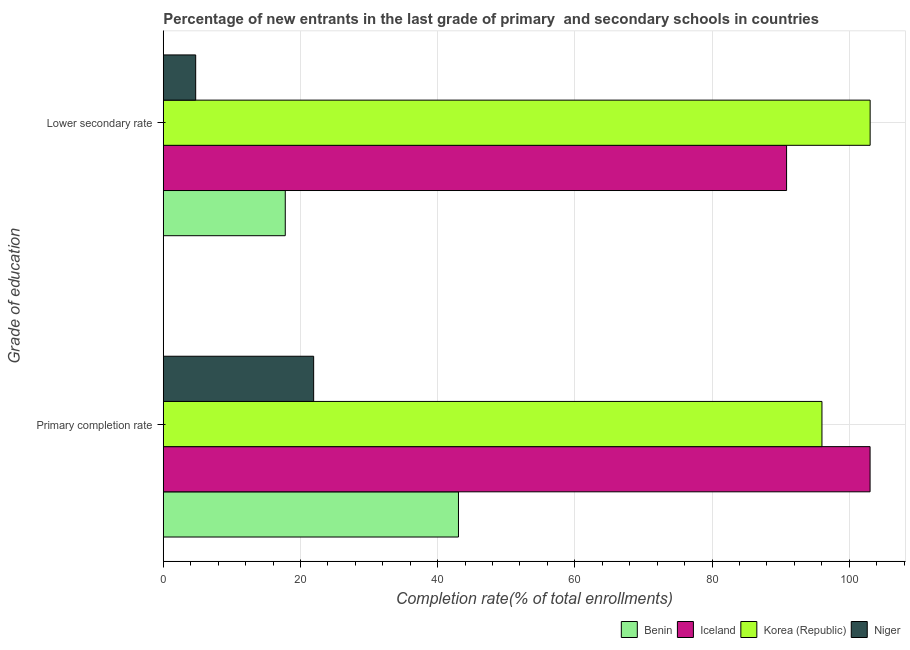How many different coloured bars are there?
Your answer should be compact. 4. Are the number of bars on each tick of the Y-axis equal?
Provide a short and direct response. Yes. How many bars are there on the 1st tick from the top?
Your response must be concise. 4. How many bars are there on the 2nd tick from the bottom?
Keep it short and to the point. 4. What is the label of the 2nd group of bars from the top?
Keep it short and to the point. Primary completion rate. What is the completion rate in secondary schools in Benin?
Offer a very short reply. 17.78. Across all countries, what is the maximum completion rate in secondary schools?
Offer a very short reply. 103.05. Across all countries, what is the minimum completion rate in primary schools?
Offer a terse response. 21.92. In which country was the completion rate in primary schools minimum?
Offer a very short reply. Niger. What is the total completion rate in secondary schools in the graph?
Provide a succinct answer. 216.42. What is the difference between the completion rate in secondary schools in Niger and that in Iceland?
Provide a succinct answer. -86.14. What is the difference between the completion rate in secondary schools in Korea (Republic) and the completion rate in primary schools in Benin?
Provide a short and direct response. 60.01. What is the average completion rate in primary schools per country?
Your answer should be compact. 66. What is the difference between the completion rate in secondary schools and completion rate in primary schools in Niger?
Provide a short and direct response. -17.2. What is the ratio of the completion rate in secondary schools in Niger to that in Benin?
Offer a terse response. 0.27. In how many countries, is the completion rate in secondary schools greater than the average completion rate in secondary schools taken over all countries?
Ensure brevity in your answer.  2. What does the 3rd bar from the top in Lower secondary rate represents?
Your answer should be compact. Iceland. What does the 3rd bar from the bottom in Lower secondary rate represents?
Ensure brevity in your answer.  Korea (Republic). Are all the bars in the graph horizontal?
Your answer should be compact. Yes. What is the difference between two consecutive major ticks on the X-axis?
Make the answer very short. 20. Are the values on the major ticks of X-axis written in scientific E-notation?
Offer a terse response. No. Does the graph contain grids?
Offer a terse response. Yes. How many legend labels are there?
Your answer should be compact. 4. How are the legend labels stacked?
Keep it short and to the point. Horizontal. What is the title of the graph?
Make the answer very short. Percentage of new entrants in the last grade of primary  and secondary schools in countries. Does "Aruba" appear as one of the legend labels in the graph?
Provide a short and direct response. No. What is the label or title of the X-axis?
Provide a succinct answer. Completion rate(% of total enrollments). What is the label or title of the Y-axis?
Give a very brief answer. Grade of education. What is the Completion rate(% of total enrollments) in Benin in Primary completion rate?
Ensure brevity in your answer.  43.03. What is the Completion rate(% of total enrollments) of Iceland in Primary completion rate?
Provide a short and direct response. 103.04. What is the Completion rate(% of total enrollments) in Korea (Republic) in Primary completion rate?
Your response must be concise. 96.02. What is the Completion rate(% of total enrollments) of Niger in Primary completion rate?
Keep it short and to the point. 21.92. What is the Completion rate(% of total enrollments) in Benin in Lower secondary rate?
Your answer should be compact. 17.78. What is the Completion rate(% of total enrollments) in Iceland in Lower secondary rate?
Your response must be concise. 90.86. What is the Completion rate(% of total enrollments) in Korea (Republic) in Lower secondary rate?
Make the answer very short. 103.05. What is the Completion rate(% of total enrollments) in Niger in Lower secondary rate?
Your answer should be compact. 4.73. Across all Grade of education, what is the maximum Completion rate(% of total enrollments) in Benin?
Keep it short and to the point. 43.03. Across all Grade of education, what is the maximum Completion rate(% of total enrollments) of Iceland?
Give a very brief answer. 103.04. Across all Grade of education, what is the maximum Completion rate(% of total enrollments) in Korea (Republic)?
Your answer should be compact. 103.05. Across all Grade of education, what is the maximum Completion rate(% of total enrollments) of Niger?
Your answer should be very brief. 21.92. Across all Grade of education, what is the minimum Completion rate(% of total enrollments) in Benin?
Your answer should be very brief. 17.78. Across all Grade of education, what is the minimum Completion rate(% of total enrollments) of Iceland?
Your answer should be compact. 90.86. Across all Grade of education, what is the minimum Completion rate(% of total enrollments) of Korea (Republic)?
Your answer should be compact. 96.02. Across all Grade of education, what is the minimum Completion rate(% of total enrollments) in Niger?
Make the answer very short. 4.73. What is the total Completion rate(% of total enrollments) in Benin in the graph?
Your response must be concise. 60.82. What is the total Completion rate(% of total enrollments) of Iceland in the graph?
Offer a terse response. 193.9. What is the total Completion rate(% of total enrollments) of Korea (Republic) in the graph?
Your answer should be compact. 199.07. What is the total Completion rate(% of total enrollments) of Niger in the graph?
Offer a terse response. 26.65. What is the difference between the Completion rate(% of total enrollments) of Benin in Primary completion rate and that in Lower secondary rate?
Keep it short and to the point. 25.25. What is the difference between the Completion rate(% of total enrollments) in Iceland in Primary completion rate and that in Lower secondary rate?
Provide a succinct answer. 12.17. What is the difference between the Completion rate(% of total enrollments) of Korea (Republic) in Primary completion rate and that in Lower secondary rate?
Your response must be concise. -7.02. What is the difference between the Completion rate(% of total enrollments) in Niger in Primary completion rate and that in Lower secondary rate?
Your answer should be very brief. 17.2. What is the difference between the Completion rate(% of total enrollments) of Benin in Primary completion rate and the Completion rate(% of total enrollments) of Iceland in Lower secondary rate?
Provide a short and direct response. -47.83. What is the difference between the Completion rate(% of total enrollments) in Benin in Primary completion rate and the Completion rate(% of total enrollments) in Korea (Republic) in Lower secondary rate?
Ensure brevity in your answer.  -60.01. What is the difference between the Completion rate(% of total enrollments) of Benin in Primary completion rate and the Completion rate(% of total enrollments) of Niger in Lower secondary rate?
Offer a very short reply. 38.31. What is the difference between the Completion rate(% of total enrollments) in Iceland in Primary completion rate and the Completion rate(% of total enrollments) in Korea (Republic) in Lower secondary rate?
Provide a short and direct response. -0.01. What is the difference between the Completion rate(% of total enrollments) of Iceland in Primary completion rate and the Completion rate(% of total enrollments) of Niger in Lower secondary rate?
Provide a succinct answer. 98.31. What is the difference between the Completion rate(% of total enrollments) of Korea (Republic) in Primary completion rate and the Completion rate(% of total enrollments) of Niger in Lower secondary rate?
Offer a very short reply. 91.3. What is the average Completion rate(% of total enrollments) in Benin per Grade of education?
Keep it short and to the point. 30.41. What is the average Completion rate(% of total enrollments) of Iceland per Grade of education?
Provide a succinct answer. 96.95. What is the average Completion rate(% of total enrollments) of Korea (Republic) per Grade of education?
Give a very brief answer. 99.53. What is the average Completion rate(% of total enrollments) of Niger per Grade of education?
Make the answer very short. 13.32. What is the difference between the Completion rate(% of total enrollments) of Benin and Completion rate(% of total enrollments) of Iceland in Primary completion rate?
Provide a succinct answer. -60. What is the difference between the Completion rate(% of total enrollments) in Benin and Completion rate(% of total enrollments) in Korea (Republic) in Primary completion rate?
Keep it short and to the point. -52.99. What is the difference between the Completion rate(% of total enrollments) in Benin and Completion rate(% of total enrollments) in Niger in Primary completion rate?
Give a very brief answer. 21.11. What is the difference between the Completion rate(% of total enrollments) of Iceland and Completion rate(% of total enrollments) of Korea (Republic) in Primary completion rate?
Offer a terse response. 7.01. What is the difference between the Completion rate(% of total enrollments) of Iceland and Completion rate(% of total enrollments) of Niger in Primary completion rate?
Offer a terse response. 81.11. What is the difference between the Completion rate(% of total enrollments) of Korea (Republic) and Completion rate(% of total enrollments) of Niger in Primary completion rate?
Offer a very short reply. 74.1. What is the difference between the Completion rate(% of total enrollments) of Benin and Completion rate(% of total enrollments) of Iceland in Lower secondary rate?
Your answer should be compact. -73.08. What is the difference between the Completion rate(% of total enrollments) in Benin and Completion rate(% of total enrollments) in Korea (Republic) in Lower secondary rate?
Make the answer very short. -85.26. What is the difference between the Completion rate(% of total enrollments) in Benin and Completion rate(% of total enrollments) in Niger in Lower secondary rate?
Keep it short and to the point. 13.06. What is the difference between the Completion rate(% of total enrollments) of Iceland and Completion rate(% of total enrollments) of Korea (Republic) in Lower secondary rate?
Provide a succinct answer. -12.18. What is the difference between the Completion rate(% of total enrollments) in Iceland and Completion rate(% of total enrollments) in Niger in Lower secondary rate?
Your answer should be compact. 86.14. What is the difference between the Completion rate(% of total enrollments) of Korea (Republic) and Completion rate(% of total enrollments) of Niger in Lower secondary rate?
Your response must be concise. 98.32. What is the ratio of the Completion rate(% of total enrollments) of Benin in Primary completion rate to that in Lower secondary rate?
Provide a succinct answer. 2.42. What is the ratio of the Completion rate(% of total enrollments) in Iceland in Primary completion rate to that in Lower secondary rate?
Provide a short and direct response. 1.13. What is the ratio of the Completion rate(% of total enrollments) of Korea (Republic) in Primary completion rate to that in Lower secondary rate?
Your answer should be very brief. 0.93. What is the ratio of the Completion rate(% of total enrollments) of Niger in Primary completion rate to that in Lower secondary rate?
Offer a very short reply. 4.64. What is the difference between the highest and the second highest Completion rate(% of total enrollments) of Benin?
Provide a succinct answer. 25.25. What is the difference between the highest and the second highest Completion rate(% of total enrollments) in Iceland?
Ensure brevity in your answer.  12.17. What is the difference between the highest and the second highest Completion rate(% of total enrollments) in Korea (Republic)?
Give a very brief answer. 7.02. What is the difference between the highest and the second highest Completion rate(% of total enrollments) of Niger?
Your response must be concise. 17.2. What is the difference between the highest and the lowest Completion rate(% of total enrollments) in Benin?
Your response must be concise. 25.25. What is the difference between the highest and the lowest Completion rate(% of total enrollments) of Iceland?
Make the answer very short. 12.17. What is the difference between the highest and the lowest Completion rate(% of total enrollments) in Korea (Republic)?
Make the answer very short. 7.02. What is the difference between the highest and the lowest Completion rate(% of total enrollments) of Niger?
Your response must be concise. 17.2. 